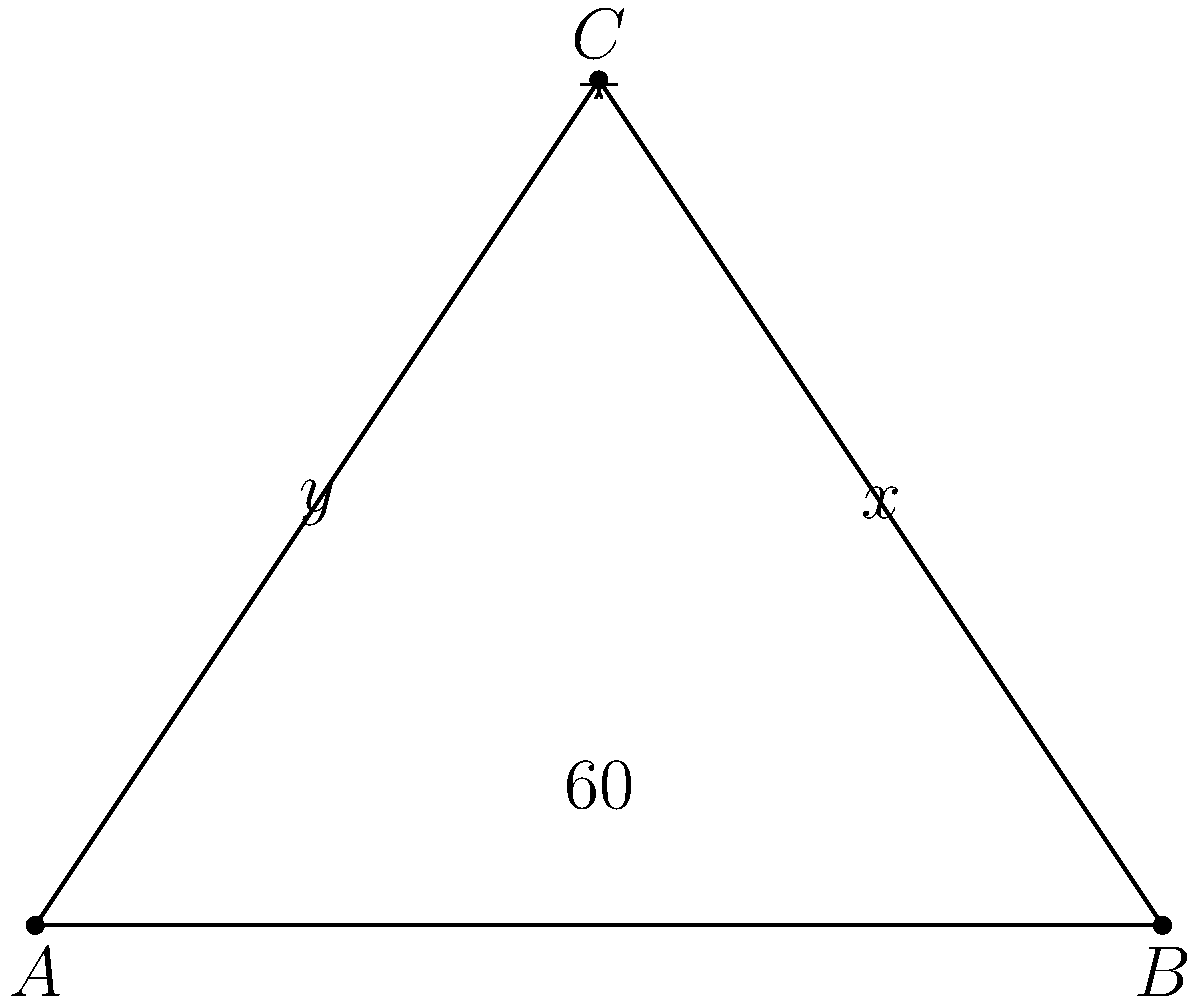As a celebrity stylist, you're organizing your client's makeup brushes. You notice that two brushes intersect, forming a triangle with the vanity surface. If the angle between one brush and the surface is 60°, and the angles formed by the intersection of the brushes with the opposite sides of the triangle are x° and y°, what is the value of x + y? Let's approach this step-by-step:

1) In any triangle, the sum of all interior angles is always 180°.

2) We're given that one angle of the triangle is 60°.

3) Let's call the other two angles of the triangle x° and y°.

4) Using the triangle angle sum theorem:
   $$60° + x° + y° = 180°$$

5) We're asked to find x + y. We can rearrange the equation:
   $$x° + y° = 180° - 60°$$

6) Simplifying:
   $$x° + y° = 120°$$

Therefore, the sum of x and y is 120°.
Answer: 120° 